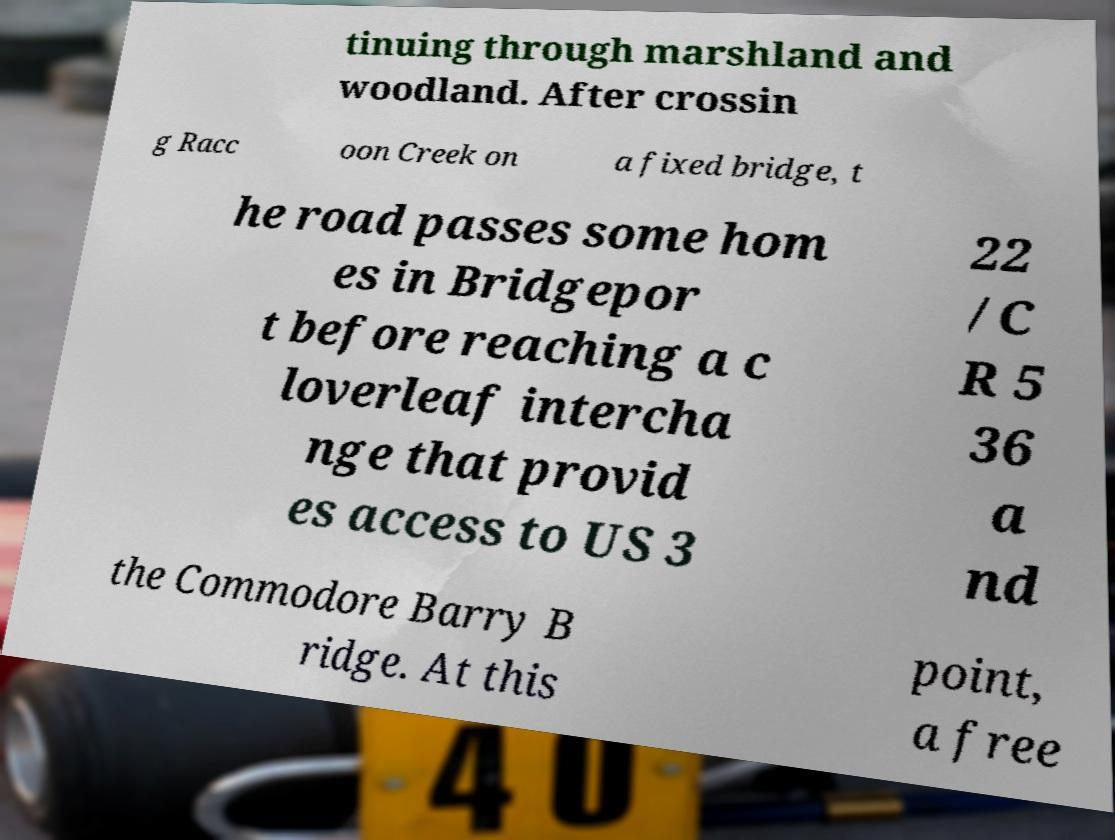Please identify and transcribe the text found in this image. tinuing through marshland and woodland. After crossin g Racc oon Creek on a fixed bridge, t he road passes some hom es in Bridgepor t before reaching a c loverleaf intercha nge that provid es access to US 3 22 /C R 5 36 a nd the Commodore Barry B ridge. At this point, a free 